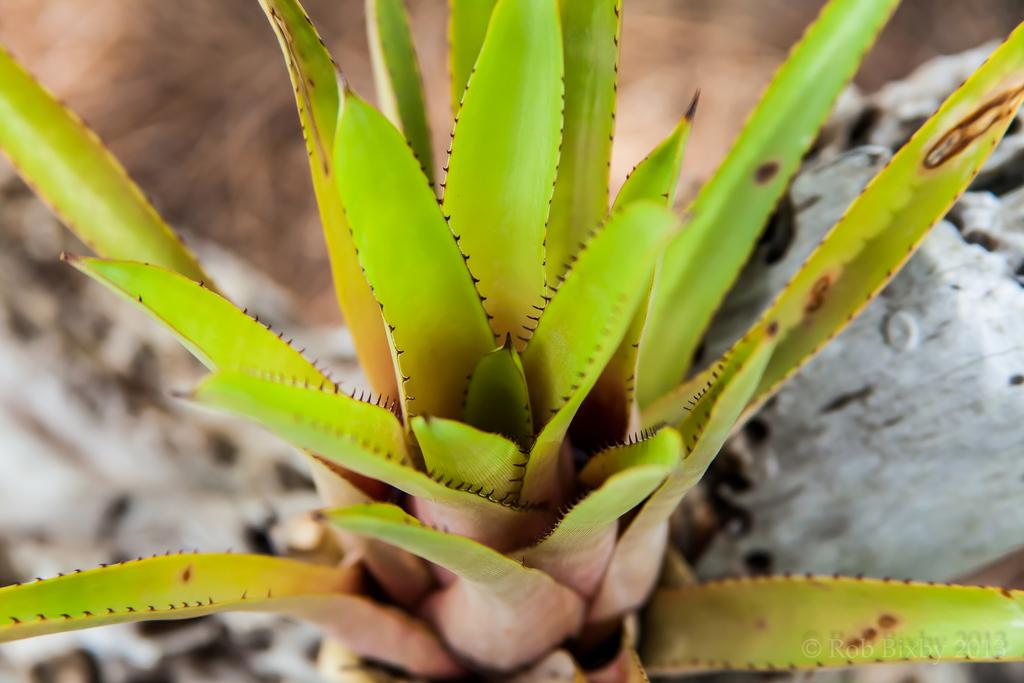What type of plant is in the image? There is an aloe Vera plant in the image. Can you describe the background of the image? The background of the image is blurred. What type of club can be seen in the image? There is no club present in the image; it features an aloe Vera plant and a blurred background. How many eyes are visible in the image? There are no eyes visible in the image. 